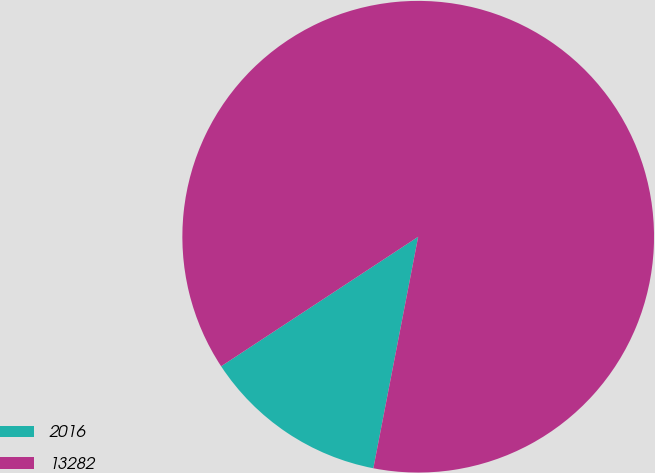Convert chart. <chart><loc_0><loc_0><loc_500><loc_500><pie_chart><fcel>2016<fcel>13282<nl><fcel>12.7%<fcel>87.3%<nl></chart> 